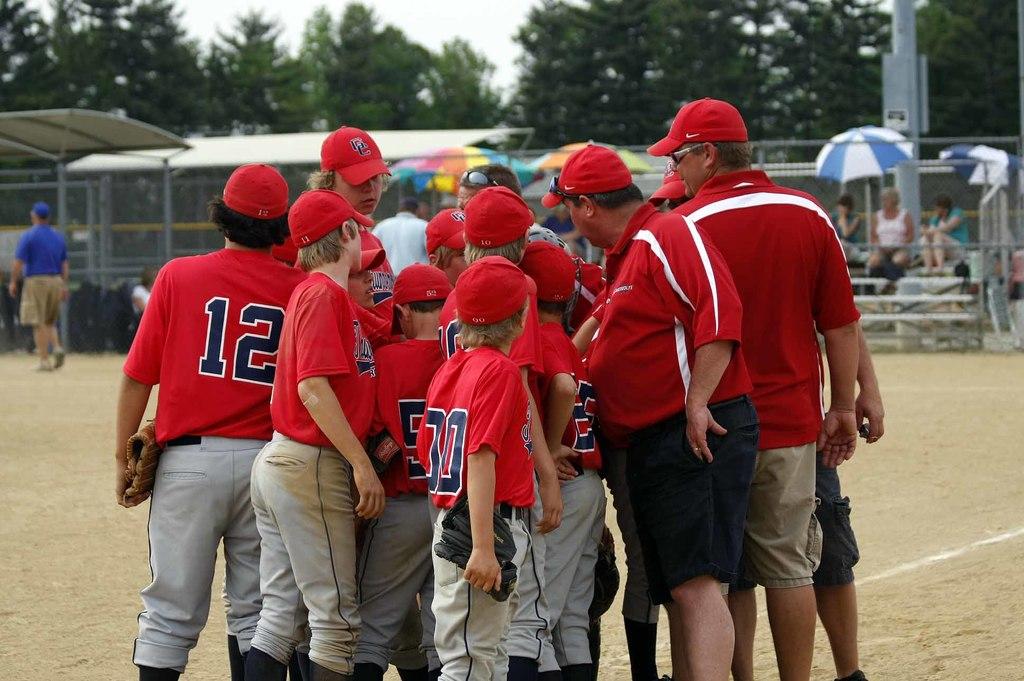What number is on the middle player?
Offer a very short reply. 30. 